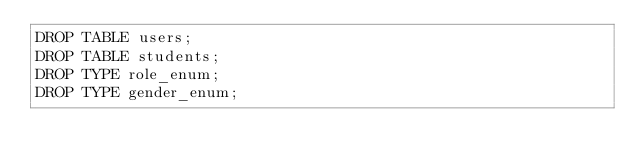<code> <loc_0><loc_0><loc_500><loc_500><_SQL_>DROP TABLE users;
DROP TABLE students;
DROP TYPE role_enum;
DROP TYPE gender_enum;</code> 